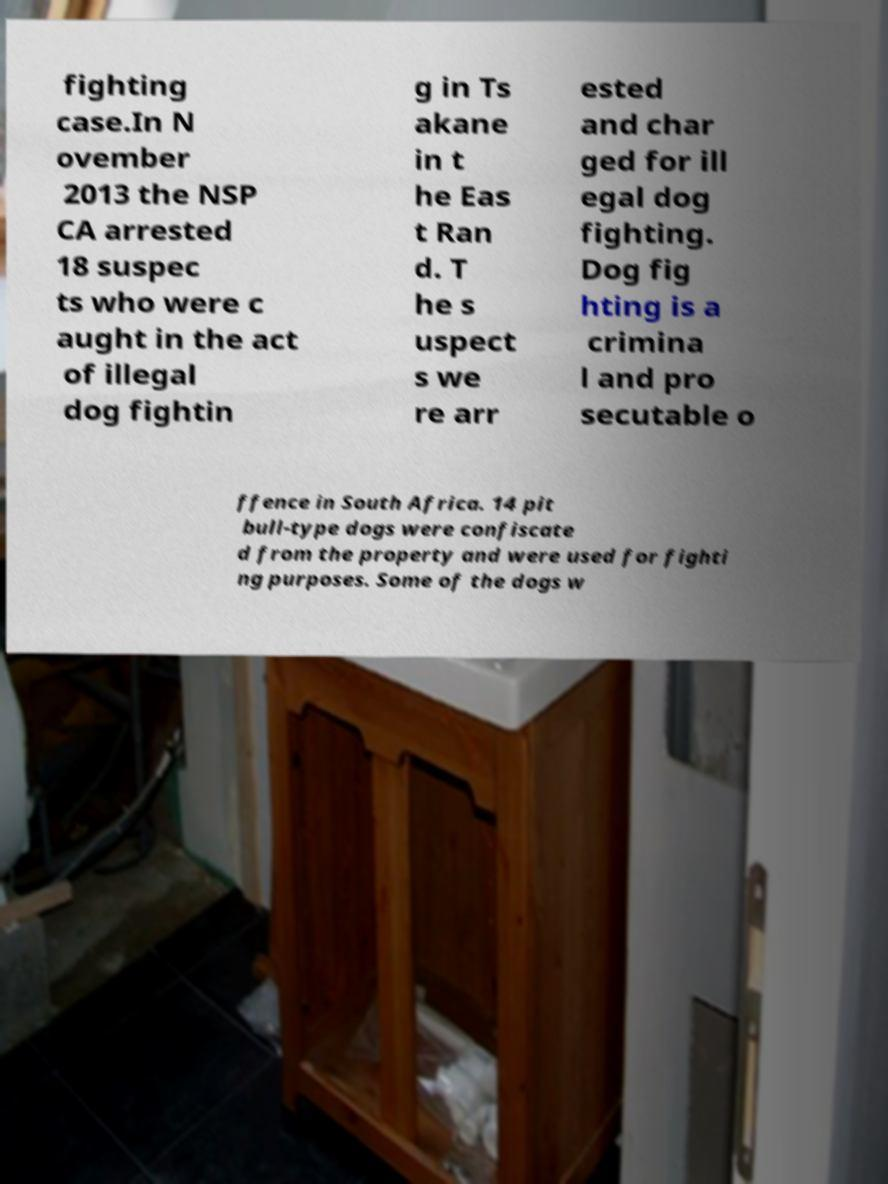Please identify and transcribe the text found in this image. fighting case.In N ovember 2013 the NSP CA arrested 18 suspec ts who were c aught in the act of illegal dog fightin g in Ts akane in t he Eas t Ran d. T he s uspect s we re arr ested and char ged for ill egal dog fighting. Dog fig hting is a crimina l and pro secutable o ffence in South Africa. 14 pit bull-type dogs were confiscate d from the property and were used for fighti ng purposes. Some of the dogs w 